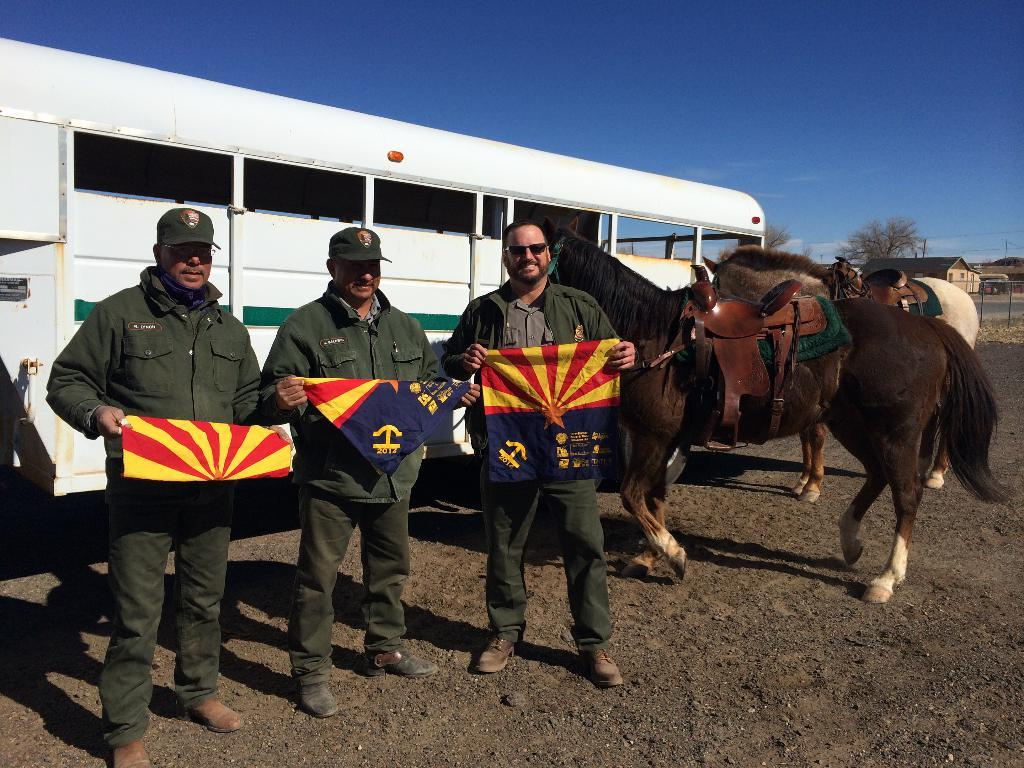How many people are present in the image? There are three people in the image. What are the people doing in the image? The people are standing and holding flags. What are the people wearing in the image? The people are wearing uniforms. What other animals can be seen in the image besides the people? There are horses in the image. What type of vehicle is present in the image? There is a bus in the image. What structures can be seen in the background of the image? There are sheds in the background of the image. What natural elements can be seen in the background of the image? There are trees and the sky visible in the background of the image. What scientific theory is being discussed by the people in the image? There is no indication in the image that the people are discussing any scientific theory. 